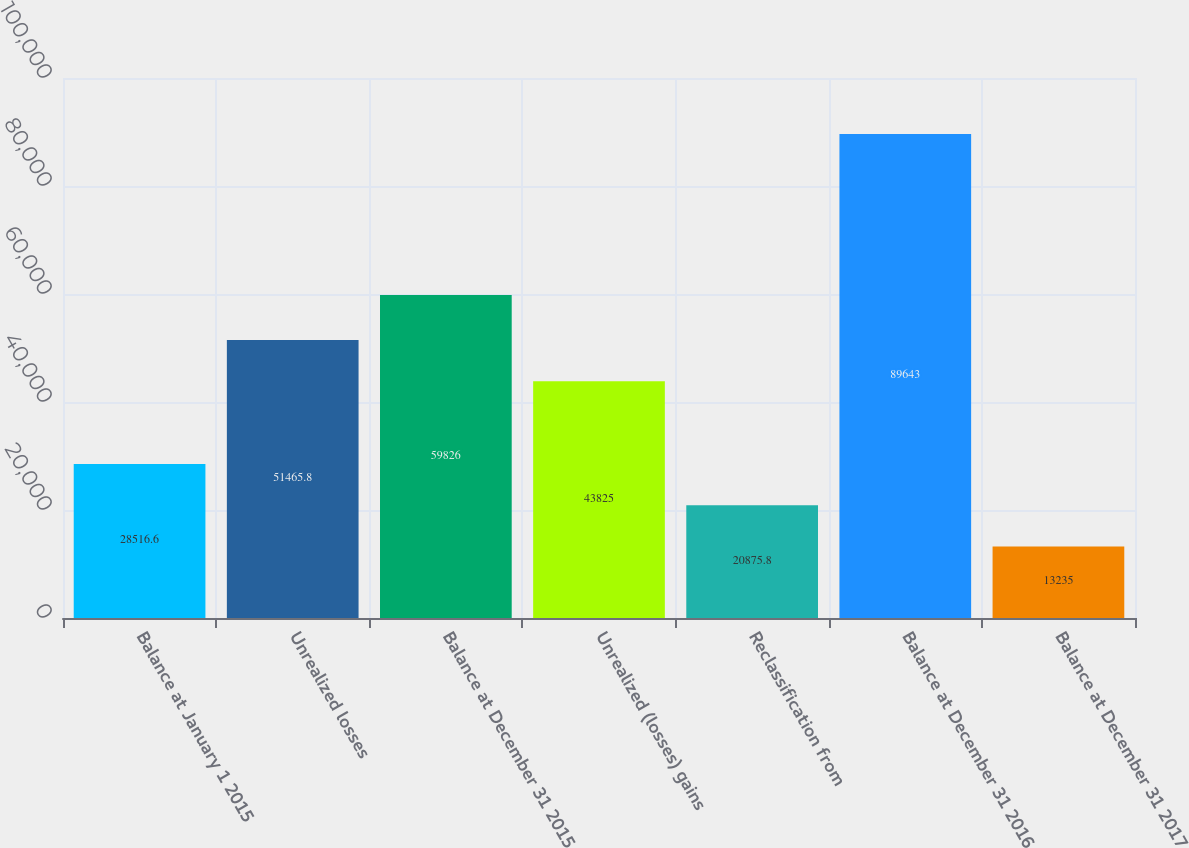Convert chart to OTSL. <chart><loc_0><loc_0><loc_500><loc_500><bar_chart><fcel>Balance at January 1 2015<fcel>Unrealized losses<fcel>Balance at December 31 2015<fcel>Unrealized (losses) gains<fcel>Reclassification from<fcel>Balance at December 31 2016<fcel>Balance at December 31 2017<nl><fcel>28516.6<fcel>51465.8<fcel>59826<fcel>43825<fcel>20875.8<fcel>89643<fcel>13235<nl></chart> 